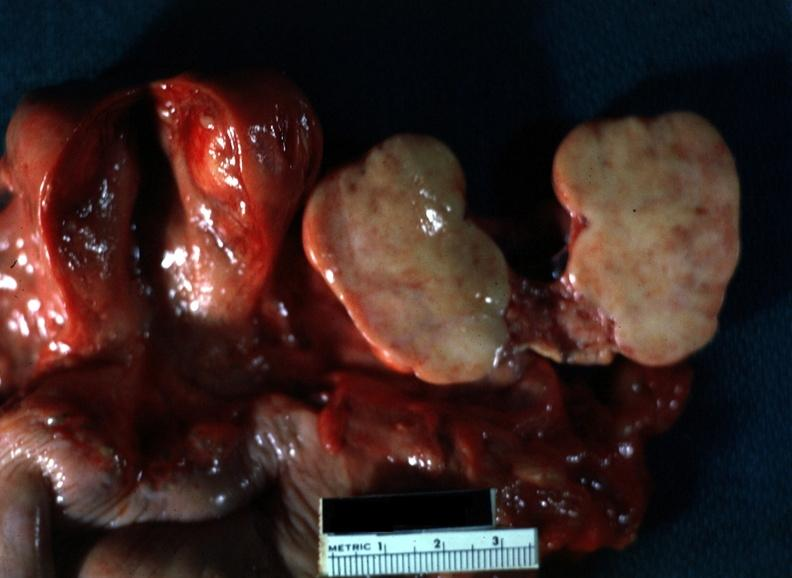what is present?
Answer the question using a single word or phrase. Ovary 